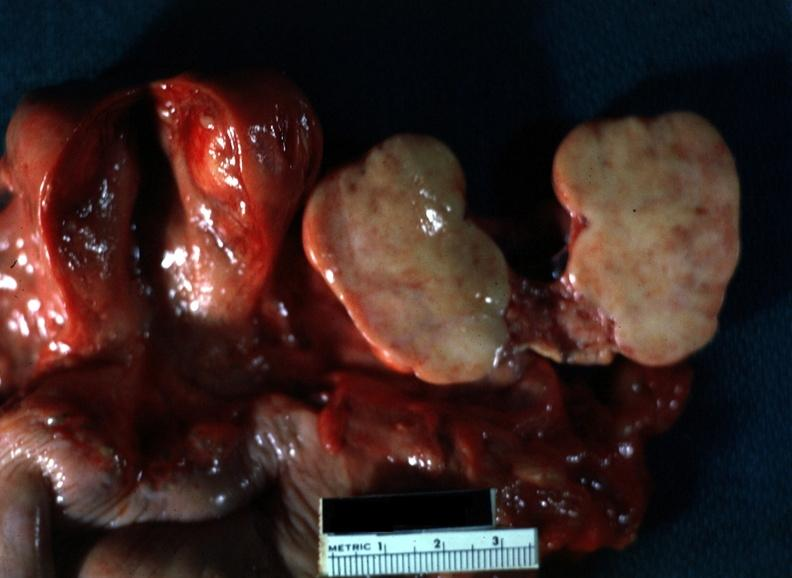what is present?
Answer the question using a single word or phrase. Ovary 